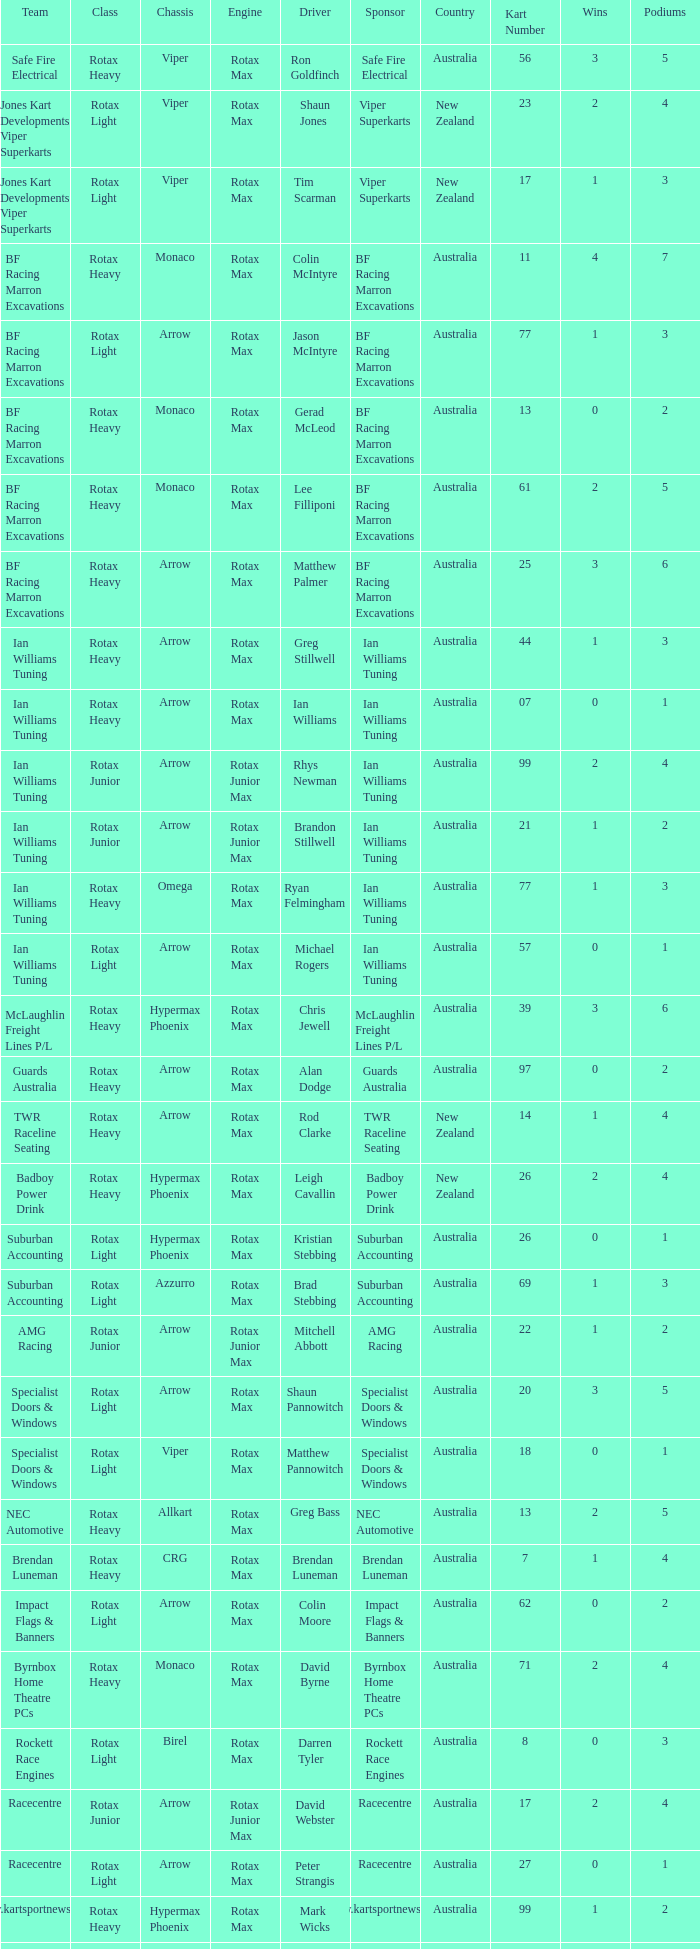Driver Shaun Jones with a viper as a chassis is in what class? Rotax Light. 